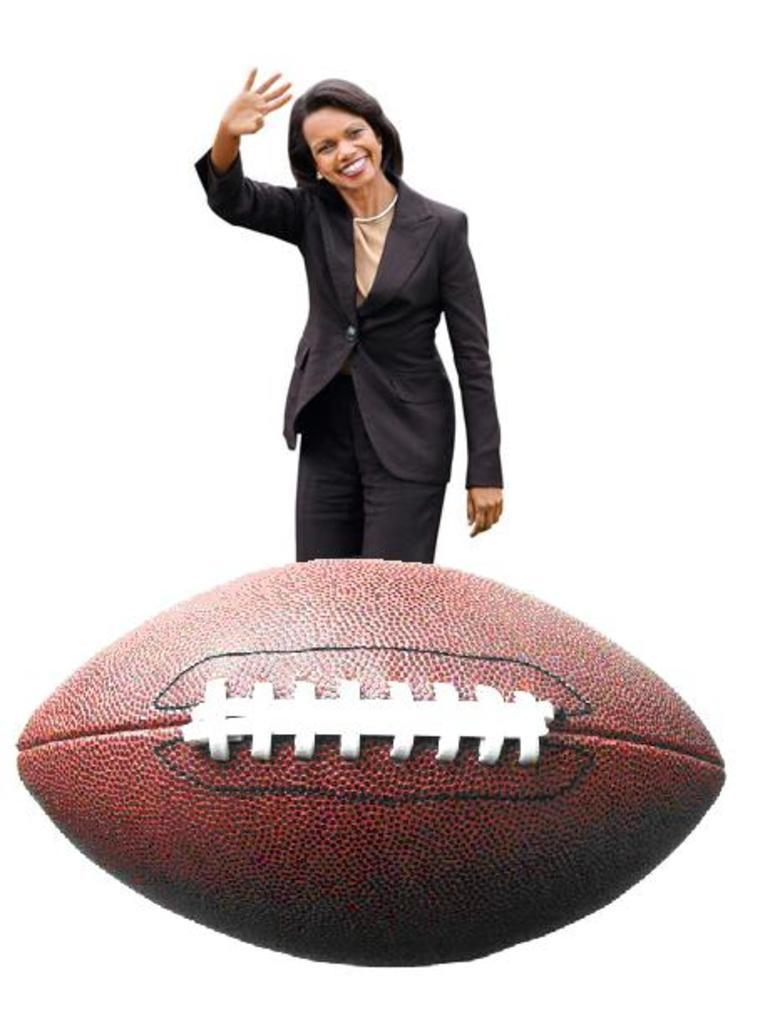Who is the main subject in the image? There is a woman in the image. What is the woman wearing? The woman is wearing a suit. What is the woman's facial expression? The woman is smiling. What is the woman doing with her hand? The woman is showing a hand. What object is in front of the woman? There is a ball in front of the woman. What is the color of the background in the image? The background of the image is white in color. What type of advertisement is the woman distributing in the image? There is no advertisement or distribution activity present in the image. 